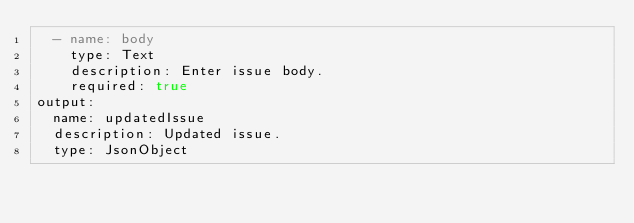<code> <loc_0><loc_0><loc_500><loc_500><_YAML_>  - name: body
    type: Text
    description: Enter issue body.
    required: true
output:
  name: updatedIssue
  description: Updated issue.
  type: JsonObject
</code> 